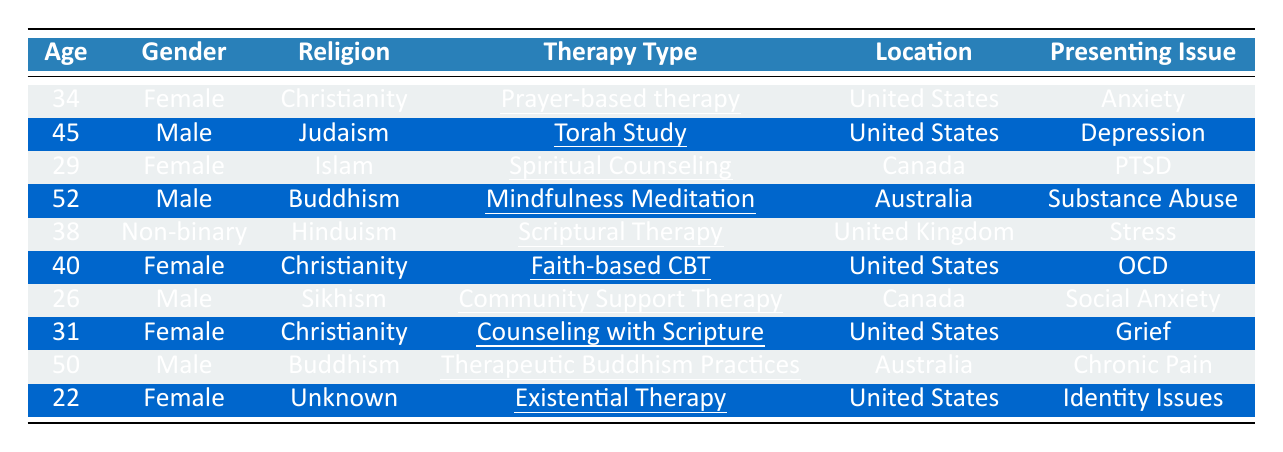What therapy type is used by the youngest client? The youngest client is 22 years old and is undergoing "Existential Therapy."
Answer: Existential Therapy How many clients are using a weekly session frequency? There are 5 clients listed with a weekly session frequency: clients with IDs 1, 3, 4, 6, and 8.
Answer: 5 What is the presenting issue for the male client from Australia? The male client from Australia is client ID 4, and his presenting issue is "Substance Abuse."
Answer: Substance Abuse Is there a non-binary client in the data? Yes, there is one non-binary client (client ID 5) listed in the data.
Answer: Yes What is the average age of the clients seeking therapy? To find the average age, add the ages of all clients: (34 + 45 + 29 + 52 + 38 + 40 + 26 + 31 + 50 + 22) = 367. There are 10 clients, so the average age is 367 / 10 = 36.7.
Answer: 36.7 What percentage of clients are female? There are 5 female clients out of 10 total clients. The percentage is (5/10) * 100 = 50%.
Answer: 50% Which therapy type is associated with "OCD" and what is the age of that client? The therapy type associated with "OCD" is "Faith-based Cognitive Behavioral Therapy" (client ID 6), and that client is 40 years old.
Answer: 40 years, Faith-based Cognitive Behavioral Therapy Which religion has the highest representation among clients in the table? Christianity has the highest representation with 4 clients (IDs 1, 6, 8, and their ages are 34, 40, and 31 respectively).
Answer: Christianity How many clients have chosen a presenting issue related to a mental health disorder? The presenting issues related to mental health disorders are "Anxiety," "Depression," "PTSD," "OCD," "Grief," and "Identity Issues," which totals 6 clients.
Answer: 6 What are the therapy types used by clients from Canada? The therapy types used by clients from Canada are "Spiritual Counseling" (client ID 3) and "Community Support Therapy" (client ID 7).
Answer: Spiritual Counseling, Community Support Therapy 